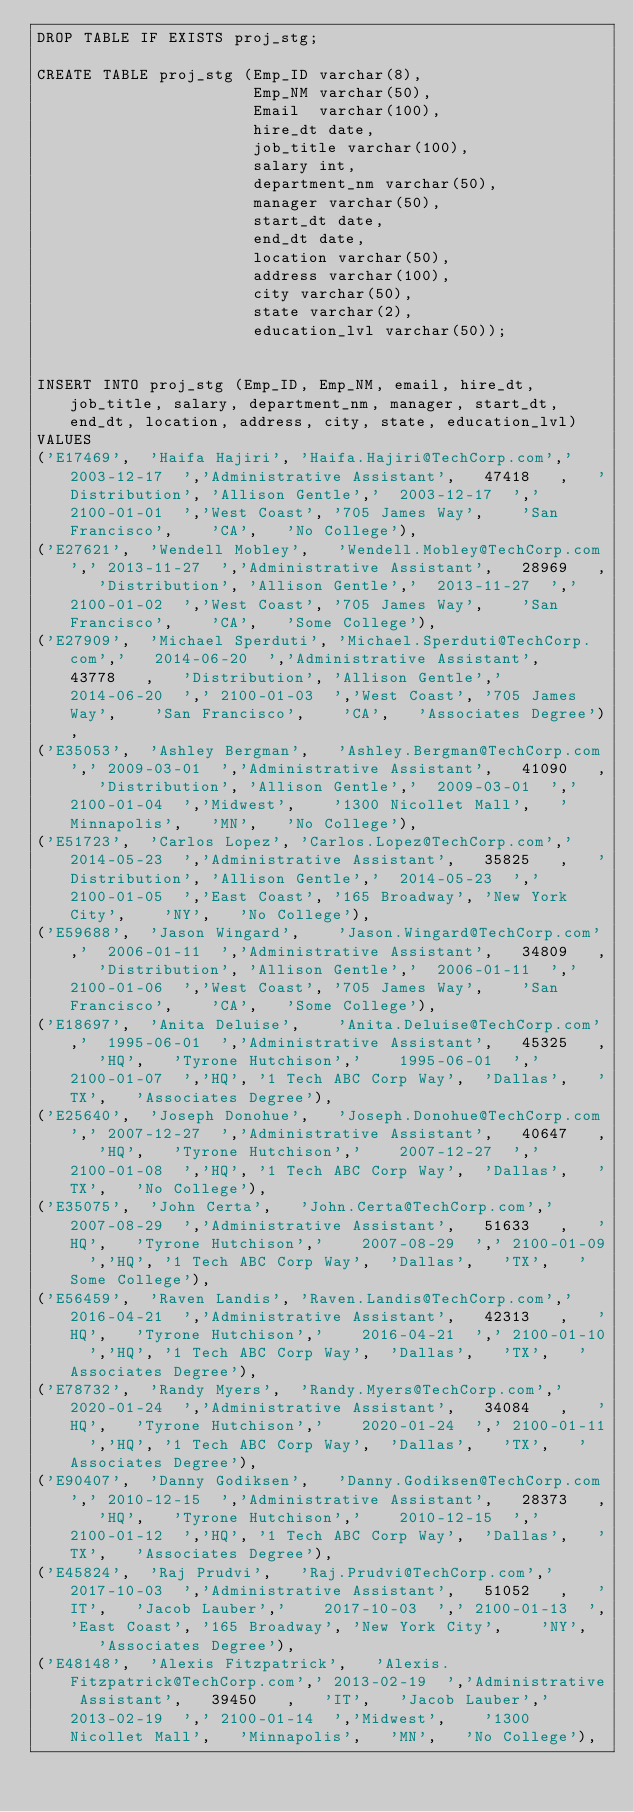Convert code to text. <code><loc_0><loc_0><loc_500><loc_500><_SQL_>DROP TABLE IF EXISTS proj_stg;

CREATE TABLE proj_stg (Emp_ID varchar(8),
                       Emp_NM varchar(50),
					   Email  varchar(100),
					   hire_dt date,
					   job_title varchar(100),
					   salary int,
					   department_nm varchar(50),
					   manager varchar(50),
					   start_dt date,
					   end_dt date,
					   location varchar(50),
					   address varchar(100),
					   city varchar(50),
					   state varchar(2),
					   education_lvl varchar(50));


INSERT INTO proj_stg (Emp_ID, Emp_NM, email, hire_dt, job_title, salary, department_nm, manager, start_dt, end_dt, location, address, city, state, education_lvl)
VALUES
('E17469',	'Haifa Hajiri',	'Haifa.Hajiri@TechCorp.com','	2003-12-17	','Administrative Assistant',	47418	,	'Distribution',	'Allison Gentle','	2003-12-17	','	2100-01-01	','West Coast',	'705 James Way',	'San Francisco',	'CA',	'No College'),
('E27621',	'Wendell Mobley',	'Wendell.Mobley@TechCorp.com','	2013-11-27	','Administrative Assistant',	28969	,	'Distribution',	'Allison Gentle','	2013-11-27	','	2100-01-02	','West Coast',	'705 James Way',	'San Francisco',	'CA',	'Some College'),
('E27909',	'Michael Sperduti',	'Michael.Sperduti@TechCorp.com','	2014-06-20	','Administrative Assistant',	43778	,	'Distribution',	'Allison Gentle','	2014-06-20	','	2100-01-03	','West Coast',	'705 James Way',	'San Francisco',	'CA',	'Associates Degree'),
('E35053',	'Ashley Bergman',	'Ashley.Bergman@TechCorp.com','	2009-03-01	','Administrative Assistant',	41090	,	'Distribution',	'Allison Gentle','	2009-03-01	','	2100-01-04	','Midwest',	'1300 Nicollet Mall',	'Minnapolis',	'MN',	'No College'),
('E51723',	'Carlos Lopez',	'Carlos.Lopez@TechCorp.com','	2014-05-23	','Administrative Assistant',	35825	,	'Distribution',	'Allison Gentle','	2014-05-23	','	2100-01-05	','East Coast',	'165 Broadway',	'New York City',	'NY',	'No College'),
('E59688',	'Jason Wingard',	'Jason.Wingard@TechCorp.com','	2006-01-11	','Administrative Assistant',	34809	,	'Distribution',	'Allison Gentle','	2006-01-11	','	2100-01-06	','West Coast',	'705 James Way',	'San Francisco',	'CA',	'Some College'),
('E18697',	'Anita Deluise',	'Anita.Deluise@TechCorp.com','	1995-06-01	','Administrative Assistant',	45325	,	'HQ',	'Tyrone Hutchison','	1995-06-01	','	2100-01-07	','HQ',	'1 Tech ABC Corp Way',	'Dallas',	'TX',	'Associates Degree'),
('E25640',	'Joseph Donohue',	'Joseph.Donohue@TechCorp.com','	2007-12-27	','Administrative Assistant',	40647	,	'HQ',	'Tyrone Hutchison','	2007-12-27	','	2100-01-08	','HQ',	'1 Tech ABC Corp Way',	'Dallas',	'TX',	'No College'),
('E35075',	'John Certa',	'John.Certa@TechCorp.com','	2007-08-29	','Administrative Assistant',	51633	,	'HQ',	'Tyrone Hutchison','	2007-08-29	','	2100-01-09	','HQ',	'1 Tech ABC Corp Way',	'Dallas',	'TX',	'Some College'),
('E56459',	'Raven Landis',	'Raven.Landis@TechCorp.com','	2016-04-21	','Administrative Assistant',	42313	,	'HQ',	'Tyrone Hutchison','	2016-04-21	','	2100-01-10	','HQ',	'1 Tech ABC Corp Way',	'Dallas',	'TX',	'Associates Degree'),
('E78732',	'Randy Myers',	'Randy.Myers@TechCorp.com','	2020-01-24	','Administrative Assistant',	34084	,	'HQ',	'Tyrone Hutchison','	2020-01-24	','	2100-01-11	','HQ',	'1 Tech ABC Corp Way',	'Dallas',	'TX',	'Associates Degree'),
('E90407',	'Danny Godiksen',	'Danny.Godiksen@TechCorp.com','	2010-12-15	','Administrative Assistant',	28373	,	'HQ',	'Tyrone Hutchison','	2010-12-15	','	2100-01-12	','HQ',	'1 Tech ABC Corp Way',	'Dallas',	'TX',	'Associates Degree'),
('E45824',	'Raj Prudvi',	'Raj.Prudvi@TechCorp.com','	2017-10-03	','Administrative Assistant',	51052	,	'IT',	'Jacob Lauber','	2017-10-03	','	2100-01-13	','East Coast',	'165 Broadway',	'New York City',	'NY',	'Associates Degree'),
('E48148',	'Alexis Fitzpatrick',	'Alexis.Fitzpatrick@TechCorp.com','	2013-02-19	','Administrative Assistant',	39450	,	'IT',	'Jacob Lauber','	2013-02-19	','	2100-01-14	','Midwest',	'1300 Nicollet Mall',	'Minnapolis',	'MN',	'No College'),</code> 